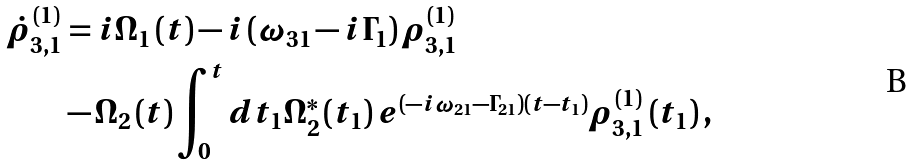<formula> <loc_0><loc_0><loc_500><loc_500>\dot { \rho } _ { 3 , 1 } ^ { ( 1 ) } & = i \Omega _ { 1 } \left ( t \right ) - i \left ( \omega _ { 3 1 } - i \Gamma _ { 1 } \right ) \rho _ { 3 , 1 } ^ { ( 1 ) } \\ & - \Omega _ { 2 } \left ( t \right ) \int _ { 0 } ^ { t } d t _ { 1 } \Omega _ { 2 } ^ { \ast } \left ( t _ { 1 } \right ) e ^ { \left ( - i \omega _ { 2 1 } - \Gamma _ { 2 1 } \right ) \left ( t - t _ { 1 } \right ) } \rho _ { 3 , 1 } ^ { ( 1 ) } \left ( t _ { 1 } \right ) ,</formula> 